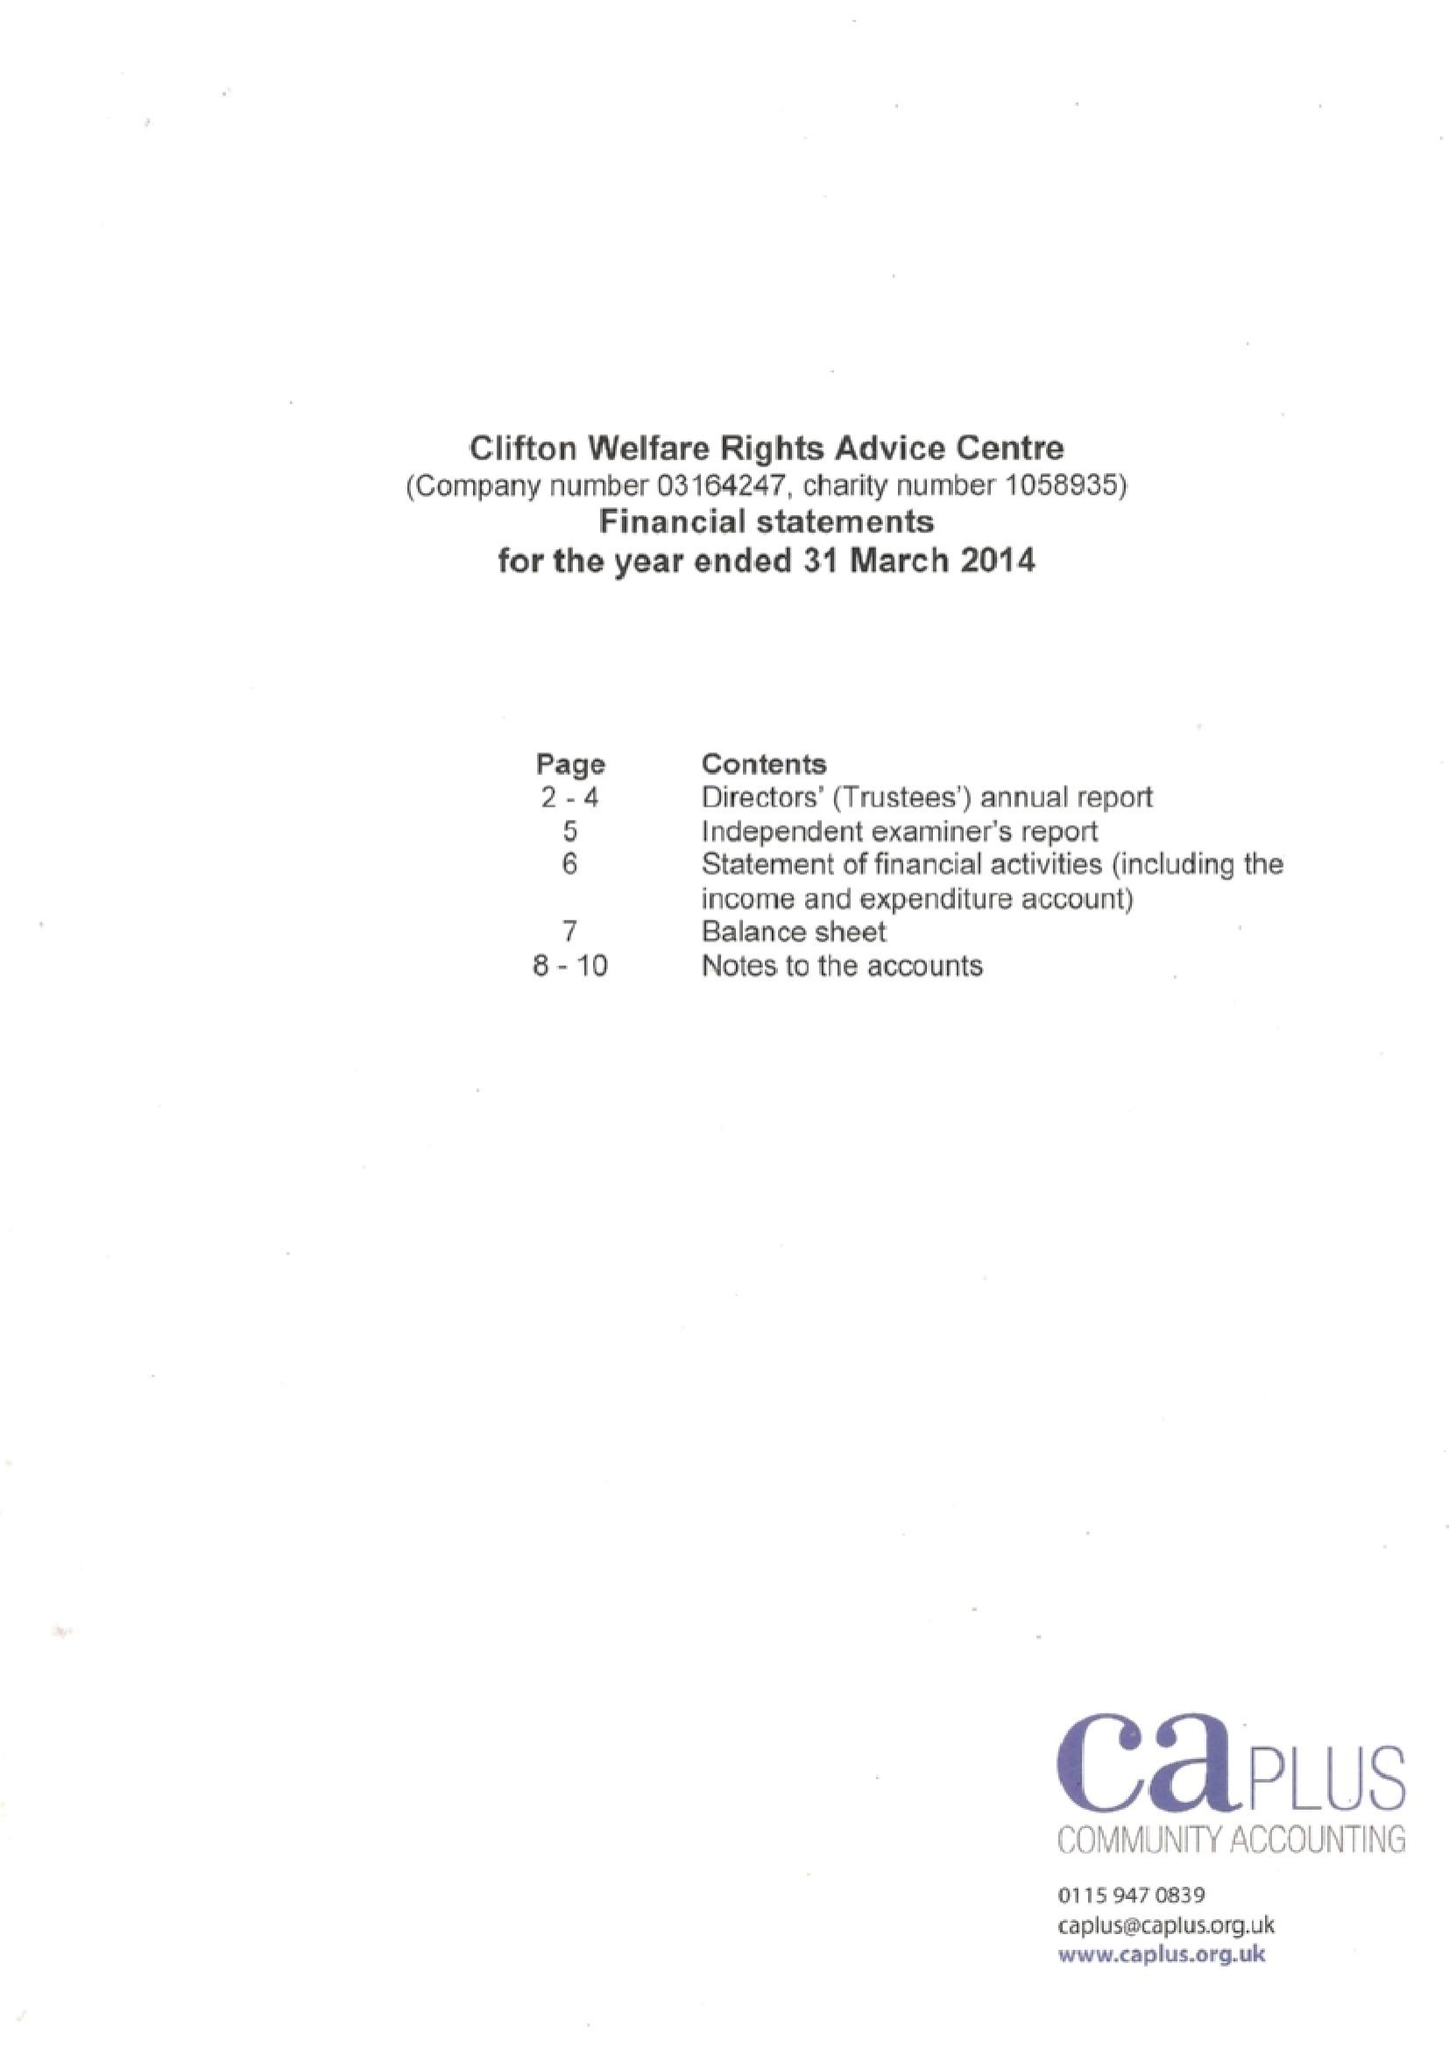What is the value for the charity_name?
Answer the question using a single word or phrase. Clifton Welfare Rights Advice Centre 